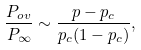<formula> <loc_0><loc_0><loc_500><loc_500>\frac { P _ { o v } } { P _ { \infty } } \sim \frac { p - p _ { c } } { p _ { c } ( 1 - p _ { c } ) } ,</formula> 